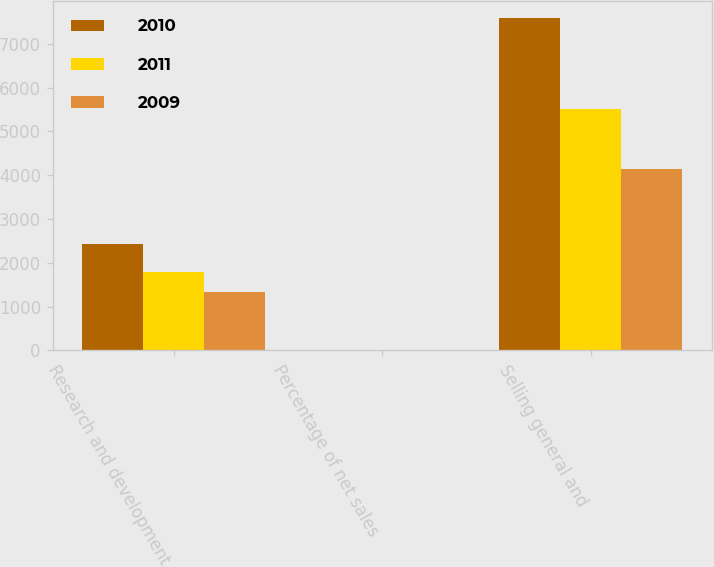Convert chart. <chart><loc_0><loc_0><loc_500><loc_500><stacked_bar_chart><ecel><fcel>Research and development<fcel>Percentage of net sales<fcel>Selling general and<nl><fcel>2010<fcel>2429<fcel>2<fcel>7599<nl><fcel>2011<fcel>1782<fcel>3<fcel>5517<nl><fcel>2009<fcel>1333<fcel>3<fcel>4149<nl></chart> 